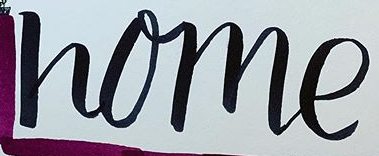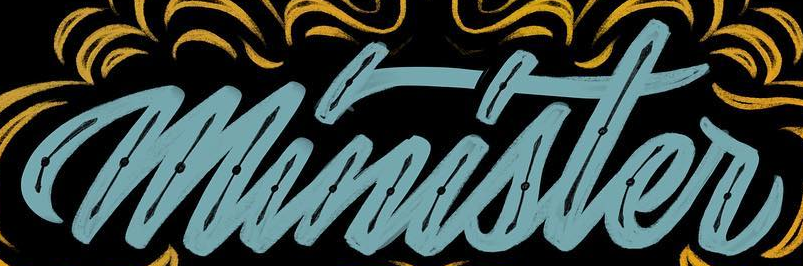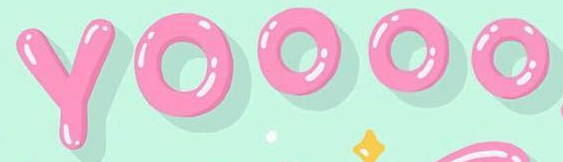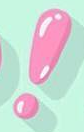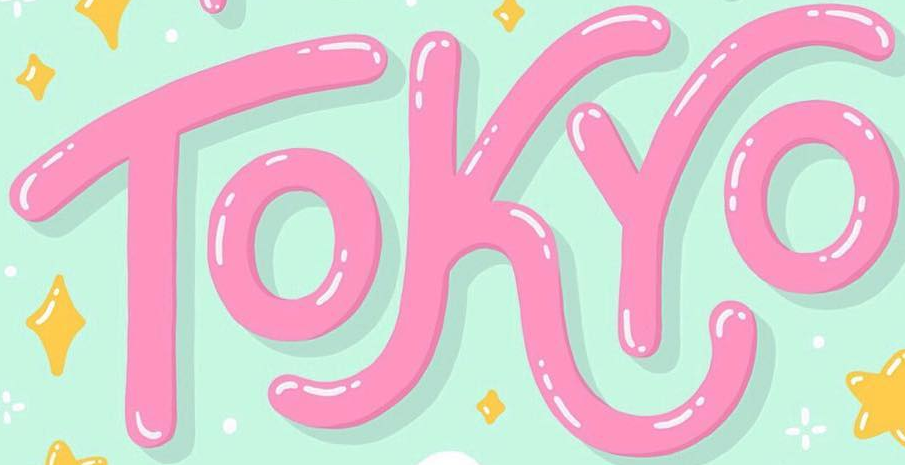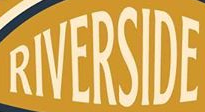Identify the words shown in these images in order, separated by a semicolon. home; minister; YOOOO; !; TOKYO; RIVERSIDE 